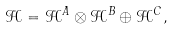<formula> <loc_0><loc_0><loc_500><loc_500>\mathcal { H } = \mathcal { H } ^ { A } \otimes \mathcal { H } ^ { B } \oplus \mathcal { H } ^ { C } ,</formula> 